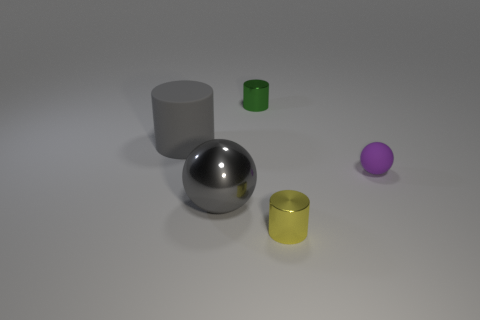Add 2 tiny purple rubber balls. How many objects exist? 7 Subtract all cylinders. How many objects are left? 2 Add 4 small brown blocks. How many small brown blocks exist? 4 Subtract 0 purple blocks. How many objects are left? 5 Subtract all small green things. Subtract all large gray matte things. How many objects are left? 3 Add 4 large metallic balls. How many large metallic balls are left? 5 